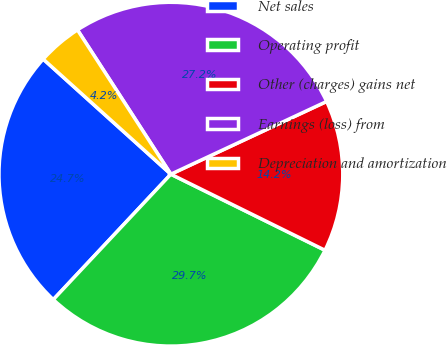Convert chart. <chart><loc_0><loc_0><loc_500><loc_500><pie_chart><fcel>Net sales<fcel>Operating profit<fcel>Other (charges) gains net<fcel>Earnings (loss) from<fcel>Depreciation and amortization<nl><fcel>24.69%<fcel>29.69%<fcel>14.25%<fcel>27.19%<fcel>4.18%<nl></chart> 